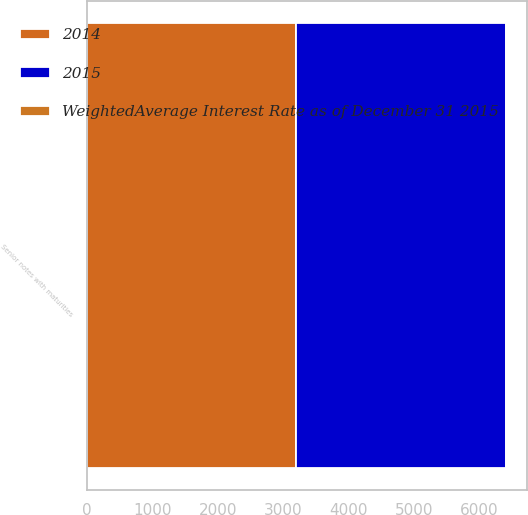<chart> <loc_0><loc_0><loc_500><loc_500><stacked_bar_chart><ecel><fcel>Senior notes with maturities<nl><fcel>WeightedAverage Interest Rate as of December 31 2015<fcel>5.62<nl><fcel>2015<fcel>3200<nl><fcel>2014<fcel>3200<nl></chart> 